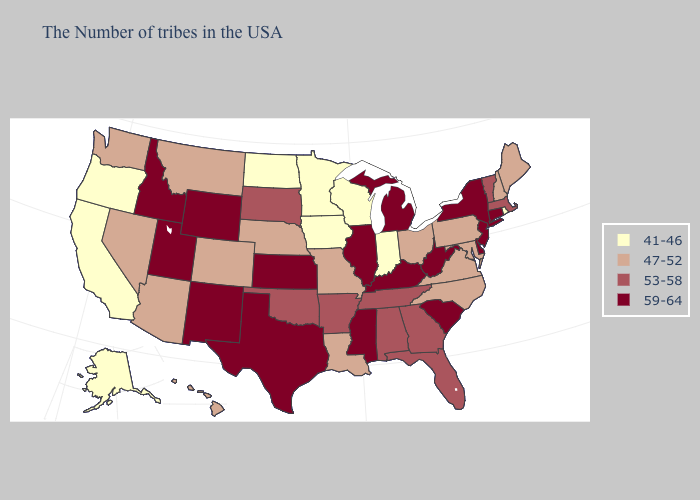Among the states that border South Dakota , does Montana have the lowest value?
Short answer required. No. What is the highest value in states that border South Carolina?
Short answer required. 53-58. Among the states that border Arizona , does New Mexico have the lowest value?
Be succinct. No. Among the states that border Pennsylvania , does Maryland have the lowest value?
Answer briefly. Yes. What is the value of Alabama?
Give a very brief answer. 53-58. Does Hawaii have the lowest value in the USA?
Quick response, please. No. Does California have a lower value than Alabama?
Quick response, please. Yes. Does the map have missing data?
Concise answer only. No. What is the lowest value in states that border Vermont?
Quick response, please. 47-52. Name the states that have a value in the range 53-58?
Write a very short answer. Massachusetts, Vermont, Florida, Georgia, Alabama, Tennessee, Arkansas, Oklahoma, South Dakota. Name the states that have a value in the range 47-52?
Concise answer only. Maine, New Hampshire, Maryland, Pennsylvania, Virginia, North Carolina, Ohio, Louisiana, Missouri, Nebraska, Colorado, Montana, Arizona, Nevada, Washington, Hawaii. Does Utah have a higher value than Illinois?
Write a very short answer. No. Does the first symbol in the legend represent the smallest category?
Keep it brief. Yes. Does Missouri have the highest value in the USA?
Answer briefly. No. Name the states that have a value in the range 41-46?
Answer briefly. Rhode Island, Indiana, Wisconsin, Minnesota, Iowa, North Dakota, California, Oregon, Alaska. 